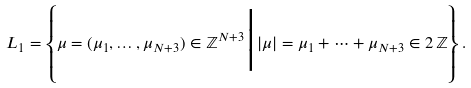Convert formula to latex. <formula><loc_0><loc_0><loc_500><loc_500>L _ { 1 } = \left \{ \mu = ( \mu _ { 1 } , \dots , \mu _ { N + 3 } ) \in \mathbb { Z } ^ { N + 3 } \Big | | \mu | = \mu _ { 1 } + \cdots + \mu _ { N + 3 } \in 2 \, \mathbb { Z } \right \} .</formula> 